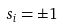<formula> <loc_0><loc_0><loc_500><loc_500>s _ { i } = \pm 1</formula> 